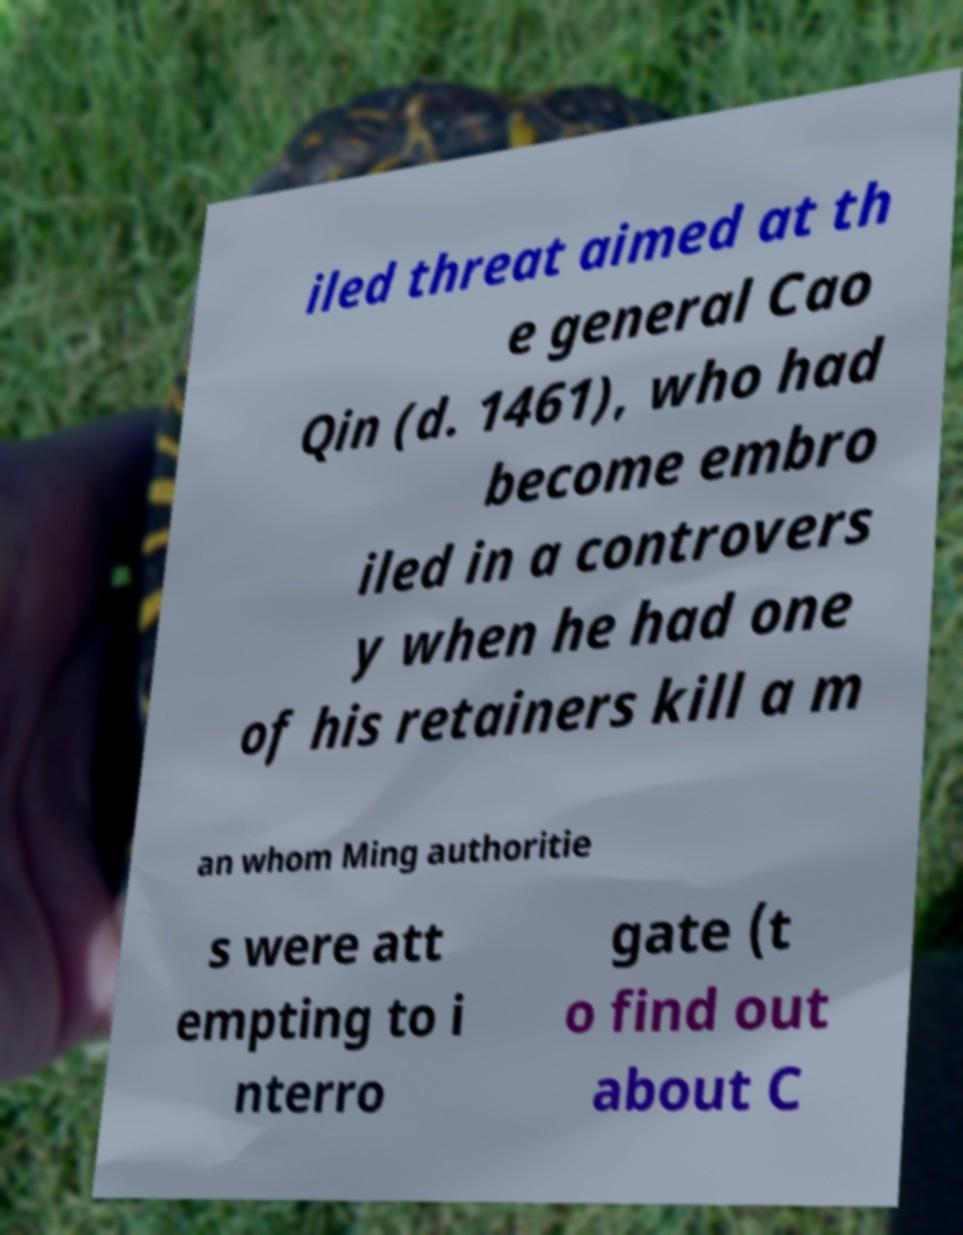I need the written content from this picture converted into text. Can you do that? iled threat aimed at th e general Cao Qin (d. 1461), who had become embro iled in a controvers y when he had one of his retainers kill a m an whom Ming authoritie s were att empting to i nterro gate (t o find out about C 